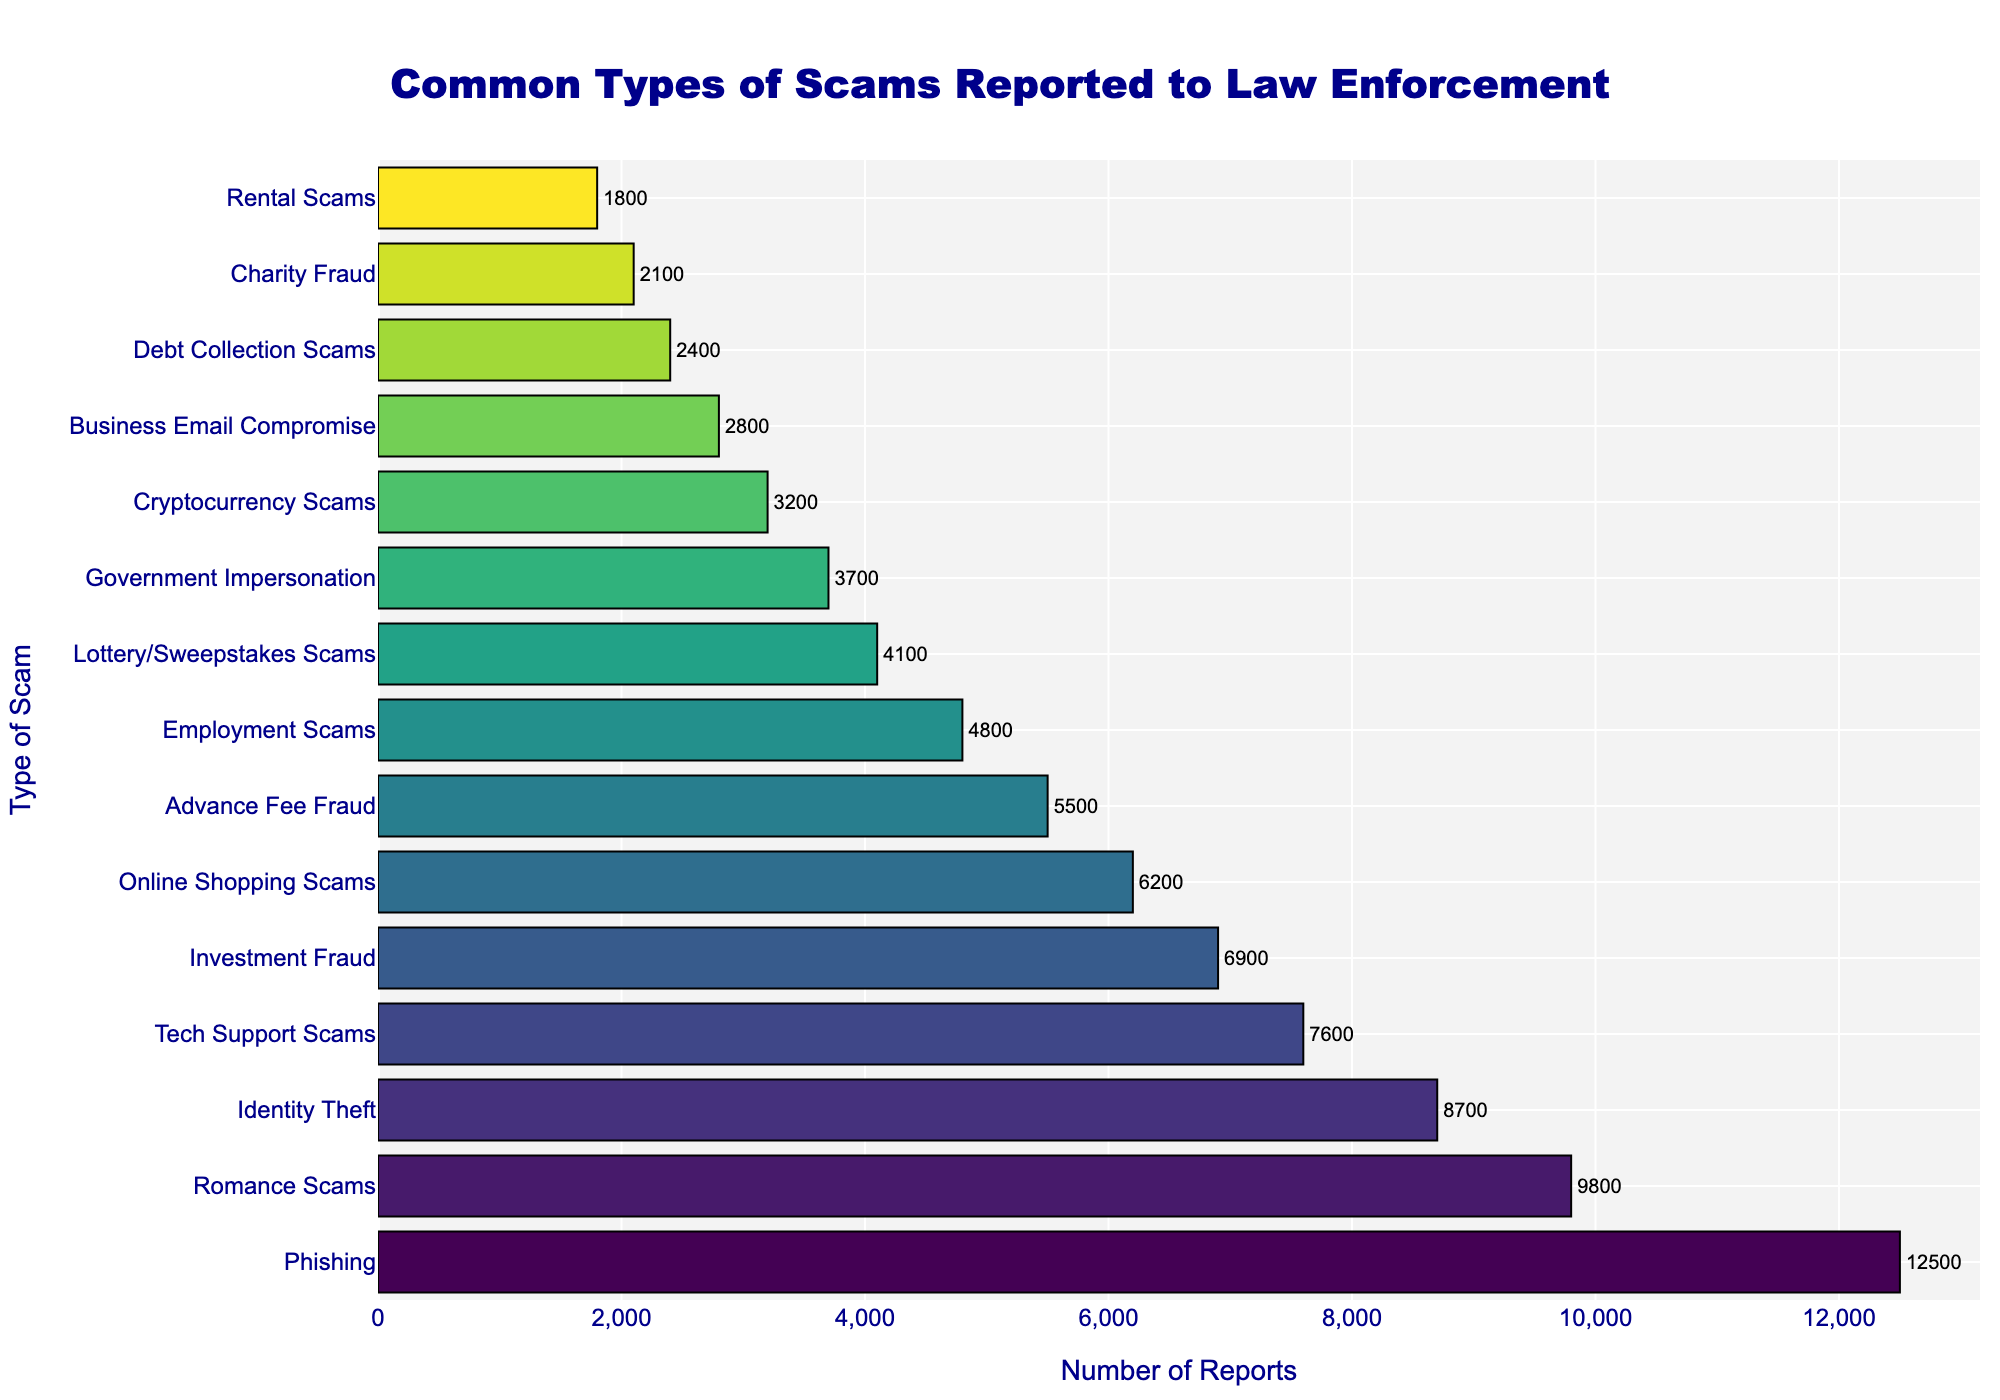What's the most commonly reported scam? The highest bar is "Phishing" with 12,500 reports. This means it's the most reported scam.
Answer: Phishing Which scam has slightly fewer reports than Romance Scams? The number of reports for Romance Scams is 9,800. The next lower bar is Identity Theft, with 8,700 reports.
Answer: Identity Theft How much greater are the reports for Tech Support Scams compared to Business Email Compromise? Tech Support Scams have 7,600 reports, and Business Email Compromise has 2,800 reports. The difference is 7,600 - 2,800 = 4,800.
Answer: 4,800 Which scam categories have fewer than 5,000 reports? The bar height for fewer than 5,000 reports is Employment Scams, Lottery/Sweepstakes Scams, Government Impersonation, Cryptocurrency Scams, Business Email Compromise, Debt Collection Scams, Charity Fraud, and Rental Scams.
Answer: Employment Scams, Lottery/Sweepstakes Scams, Government Impersonation, Cryptocurrency Scams, Business Email Compromise, Debt Collection Scams, Charity Fraud, Rental Scams What is the combined number of reports for the three least reported scams? The least reported scams are Rental Scams (1,800), Charity Fraud (2,100), and Debt Collection Scams (2,400). Their combined number of reports is 1,800 + 2,100 + 2,400 = 6,300.
Answer: 6,300 Which scams have between 3,000 and 5,000 reports? The bars that fall in this range are Government Impersonation (3,700), Lottery/Sweepstakes Scams (4,100), and Employment Scams (4,800).
Answer: Government Impersonation, Lottery/Sweepstakes Scams, Employment Scams Which scams are reported more frequently than Online Shopping Scams but less frequently than Identity Theft? The number of reports for Identity Theft is 8,700, and for Online Shopping Scams, it is 6,200. The scam with report numbers between these values is Tech Support Scams (7,600).
Answer: Tech Support Scams How do the visual heights of the bars for Advance Fee Fraud and Lottery/Sweepstakes Scams compare? The bar for Advance Fee Fraud is shorter than that for Lottery/Sweepstakes Scams, indicating fewer reports.
Answer: Advance Fee Fraud is shorter What are the total number of reports for the top five scams? The top five scams are Phishing (12,500), Romance Scams (9,800), Identity Theft (8,700), Tech Support Scams (7,600), and Investment Fraud (6,900). Their total is 12,500 + 9,800 + 8,700 + 7,600 + 6,900 = 45,500.
Answer: 45,500 